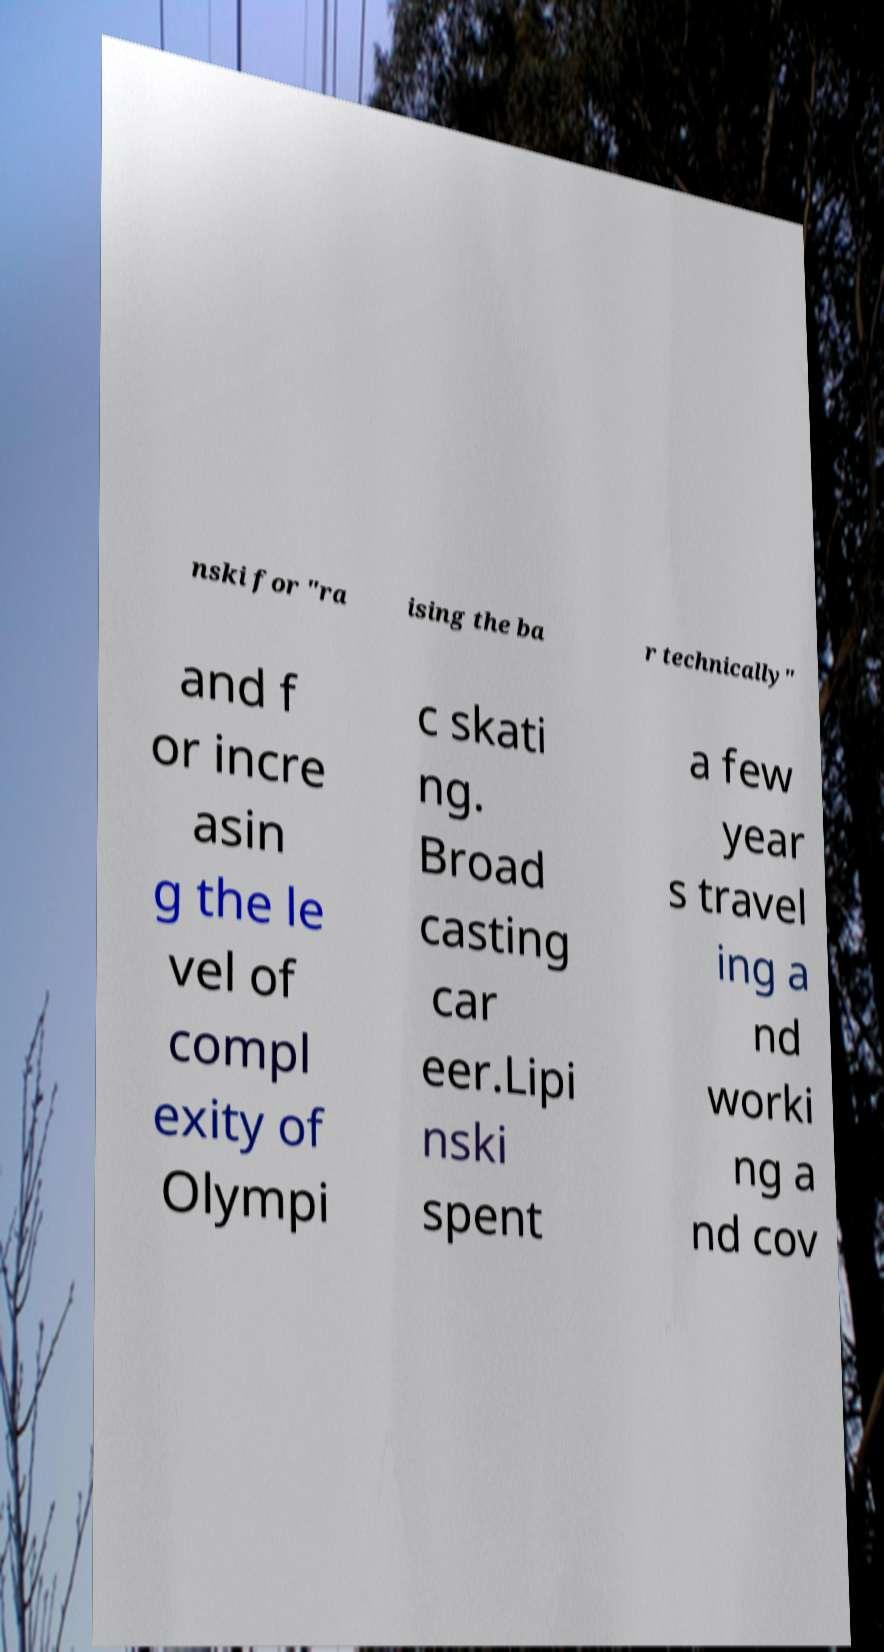Can you accurately transcribe the text from the provided image for me? nski for "ra ising the ba r technically" and f or incre asin g the le vel of compl exity of Olympi c skati ng. Broad casting car eer.Lipi nski spent a few year s travel ing a nd worki ng a nd cov 